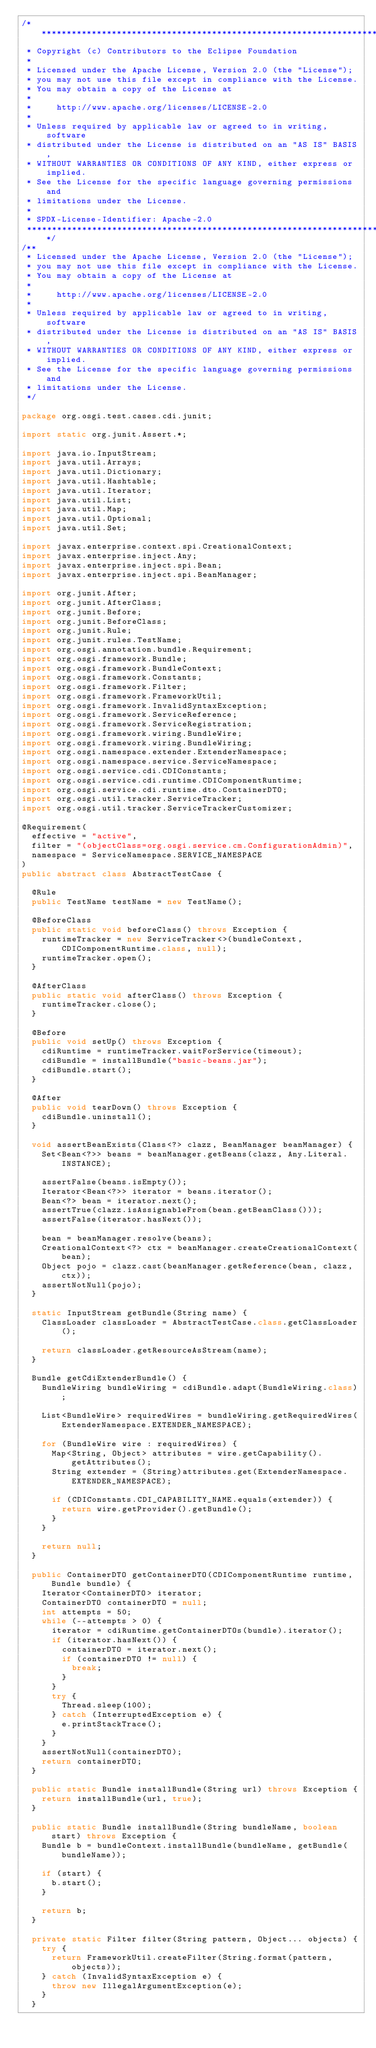Convert code to text. <code><loc_0><loc_0><loc_500><loc_500><_Java_>/*******************************************************************************
 * Copyright (c) Contributors to the Eclipse Foundation
 *
 * Licensed under the Apache License, Version 2.0 (the "License");
 * you may not use this file except in compliance with the License.
 * You may obtain a copy of the License at
 *
 *     http://www.apache.org/licenses/LICENSE-2.0
 *
 * Unless required by applicable law or agreed to in writing, software
 * distributed under the License is distributed on an "AS IS" BASIS,
 * WITHOUT WARRANTIES OR CONDITIONS OF ANY KIND, either express or implied.
 * See the License for the specific language governing permissions and
 * limitations under the License.
 *
 * SPDX-License-Identifier: Apache-2.0 
 *******************************************************************************/
/**
 * Licensed under the Apache License, Version 2.0 (the "License");
 * you may not use this file except in compliance with the License.
 * You may obtain a copy of the License at
 *
 *     http://www.apache.org/licenses/LICENSE-2.0
 *
 * Unless required by applicable law or agreed to in writing, software
 * distributed under the License is distributed on an "AS IS" BASIS,
 * WITHOUT WARRANTIES OR CONDITIONS OF ANY KIND, either express or implied.
 * See the License for the specific language governing permissions and
 * limitations under the License.
 */

package org.osgi.test.cases.cdi.junit;

import static org.junit.Assert.*;

import java.io.InputStream;
import java.util.Arrays;
import java.util.Dictionary;
import java.util.Hashtable;
import java.util.Iterator;
import java.util.List;
import java.util.Map;
import java.util.Optional;
import java.util.Set;

import javax.enterprise.context.spi.CreationalContext;
import javax.enterprise.inject.Any;
import javax.enterprise.inject.spi.Bean;
import javax.enterprise.inject.spi.BeanManager;

import org.junit.After;
import org.junit.AfterClass;
import org.junit.Before;
import org.junit.BeforeClass;
import org.junit.Rule;
import org.junit.rules.TestName;
import org.osgi.annotation.bundle.Requirement;
import org.osgi.framework.Bundle;
import org.osgi.framework.BundleContext;
import org.osgi.framework.Constants;
import org.osgi.framework.Filter;
import org.osgi.framework.FrameworkUtil;
import org.osgi.framework.InvalidSyntaxException;
import org.osgi.framework.ServiceReference;
import org.osgi.framework.ServiceRegistration;
import org.osgi.framework.wiring.BundleWire;
import org.osgi.framework.wiring.BundleWiring;
import org.osgi.namespace.extender.ExtenderNamespace;
import org.osgi.namespace.service.ServiceNamespace;
import org.osgi.service.cdi.CDIConstants;
import org.osgi.service.cdi.runtime.CDIComponentRuntime;
import org.osgi.service.cdi.runtime.dto.ContainerDTO;
import org.osgi.util.tracker.ServiceTracker;
import org.osgi.util.tracker.ServiceTrackerCustomizer;

@Requirement(
	effective = "active",
	filter = "(objectClass=org.osgi.service.cm.ConfigurationAdmin)",
	namespace = ServiceNamespace.SERVICE_NAMESPACE
)
public abstract class AbstractTestCase {

	@Rule
	public TestName testName = new TestName();

	@BeforeClass
	public static void beforeClass() throws Exception {
		runtimeTracker = new ServiceTracker<>(bundleContext, CDIComponentRuntime.class, null);
		runtimeTracker.open();
	}

	@AfterClass
	public static void afterClass() throws Exception {
		runtimeTracker.close();
	}

	@Before
	public void setUp() throws Exception {
		cdiRuntime = runtimeTracker.waitForService(timeout);
		cdiBundle = installBundle("basic-beans.jar");
		cdiBundle.start();
	}

	@After
	public void tearDown() throws Exception {
		cdiBundle.uninstall();
	}

	void assertBeanExists(Class<?> clazz, BeanManager beanManager) {
		Set<Bean<?>> beans = beanManager.getBeans(clazz, Any.Literal.INSTANCE);

		assertFalse(beans.isEmpty());
		Iterator<Bean<?>> iterator = beans.iterator();
		Bean<?> bean = iterator.next();
		assertTrue(clazz.isAssignableFrom(bean.getBeanClass()));
		assertFalse(iterator.hasNext());

		bean = beanManager.resolve(beans);
		CreationalContext<?> ctx = beanManager.createCreationalContext(bean);
		Object pojo = clazz.cast(beanManager.getReference(bean, clazz, ctx));
		assertNotNull(pojo);
	}

	static InputStream getBundle(String name) {
		ClassLoader classLoader = AbstractTestCase.class.getClassLoader();

		return classLoader.getResourceAsStream(name);
	}

	Bundle getCdiExtenderBundle() {
		BundleWiring bundleWiring = cdiBundle.adapt(BundleWiring.class);

		List<BundleWire> requiredWires = bundleWiring.getRequiredWires(ExtenderNamespace.EXTENDER_NAMESPACE);

		for (BundleWire wire : requiredWires) {
			Map<String, Object> attributes = wire.getCapability().getAttributes();
			String extender = (String)attributes.get(ExtenderNamespace.EXTENDER_NAMESPACE);

			if (CDIConstants.CDI_CAPABILITY_NAME.equals(extender)) {
				return wire.getProvider().getBundle();
			}
		}

		return null;
	}

	public ContainerDTO getContainerDTO(CDIComponentRuntime runtime, Bundle bundle) {
		Iterator<ContainerDTO> iterator;
		ContainerDTO containerDTO = null;
		int attempts = 50;
		while (--attempts > 0) {
			iterator = cdiRuntime.getContainerDTOs(bundle).iterator();
			if (iterator.hasNext()) {
				containerDTO = iterator.next();
				if (containerDTO != null) {
					break;
				}
			}
			try {
				Thread.sleep(100);
			} catch (InterruptedException e) {
				e.printStackTrace();
			}
		}
		assertNotNull(containerDTO);
		return containerDTO;
	}

	public static Bundle installBundle(String url) throws Exception {
		return installBundle(url, true);
	}

	public static Bundle installBundle(String bundleName, boolean start) throws Exception {
		Bundle b = bundleContext.installBundle(bundleName, getBundle(bundleName));

		if (start) {
			b.start();
		}

		return b;
	}

	private static Filter filter(String pattern, Object... objects) {
		try {
			return FrameworkUtil.createFilter(String.format(pattern, objects));
		} catch (InvalidSyntaxException e) {
			throw new IllegalArgumentException(e);
		}
	}
</code> 